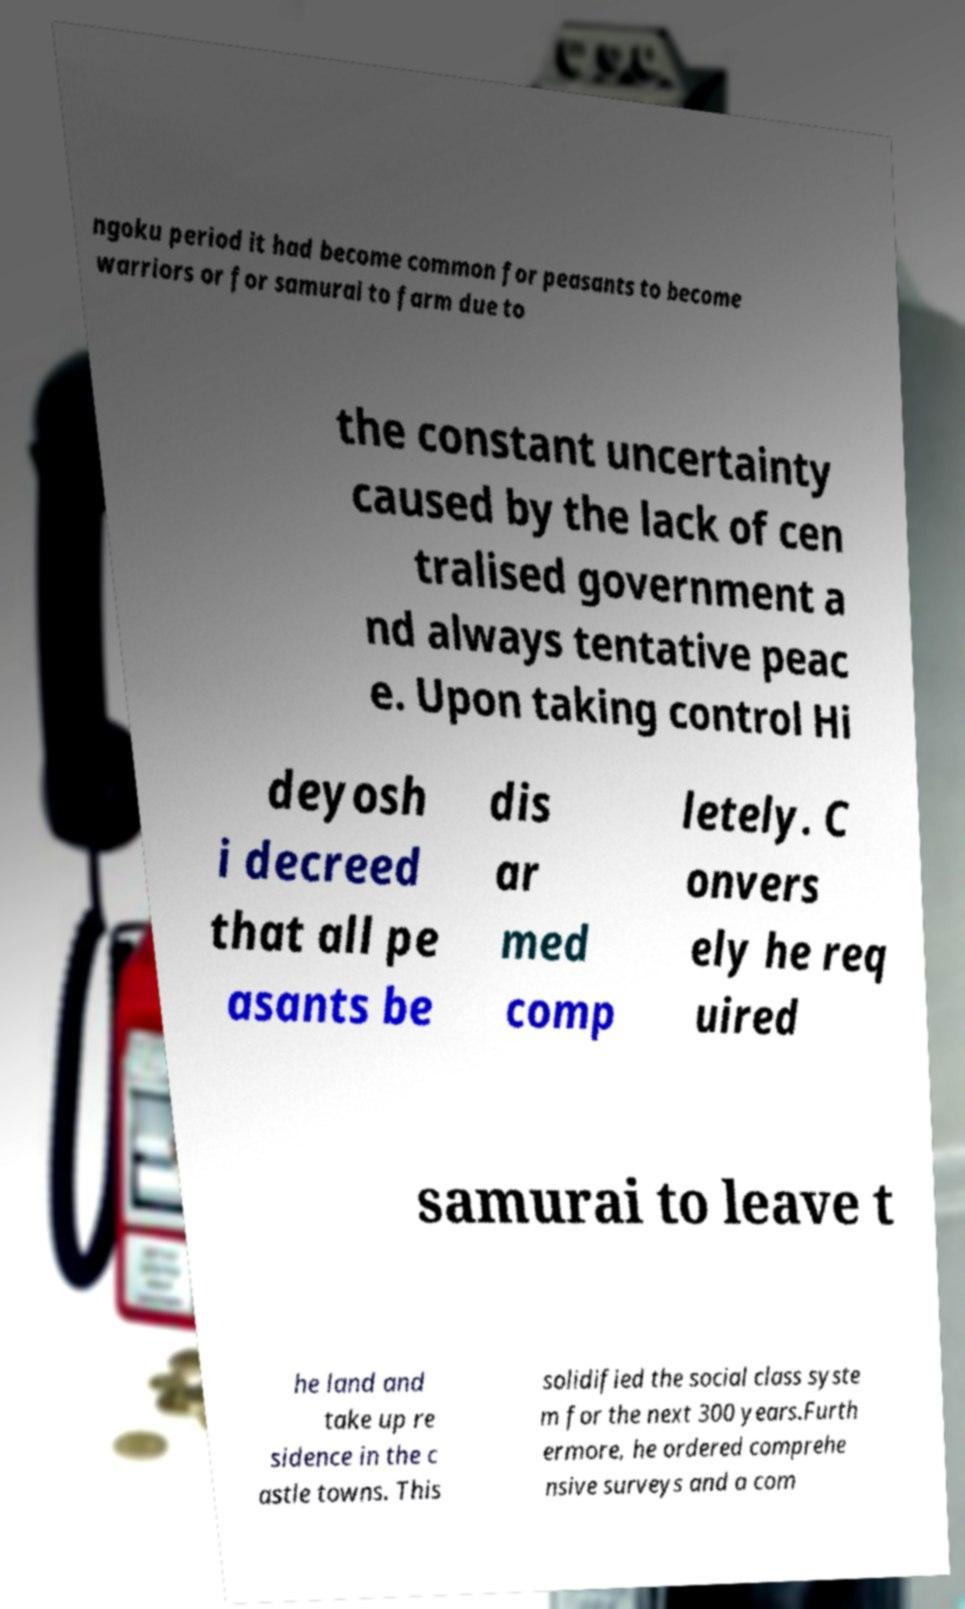Could you assist in decoding the text presented in this image and type it out clearly? ngoku period it had become common for peasants to become warriors or for samurai to farm due to the constant uncertainty caused by the lack of cen tralised government a nd always tentative peac e. Upon taking control Hi deyosh i decreed that all pe asants be dis ar med comp letely. C onvers ely he req uired samurai to leave t he land and take up re sidence in the c astle towns. This solidified the social class syste m for the next 300 years.Furth ermore, he ordered comprehe nsive surveys and a com 